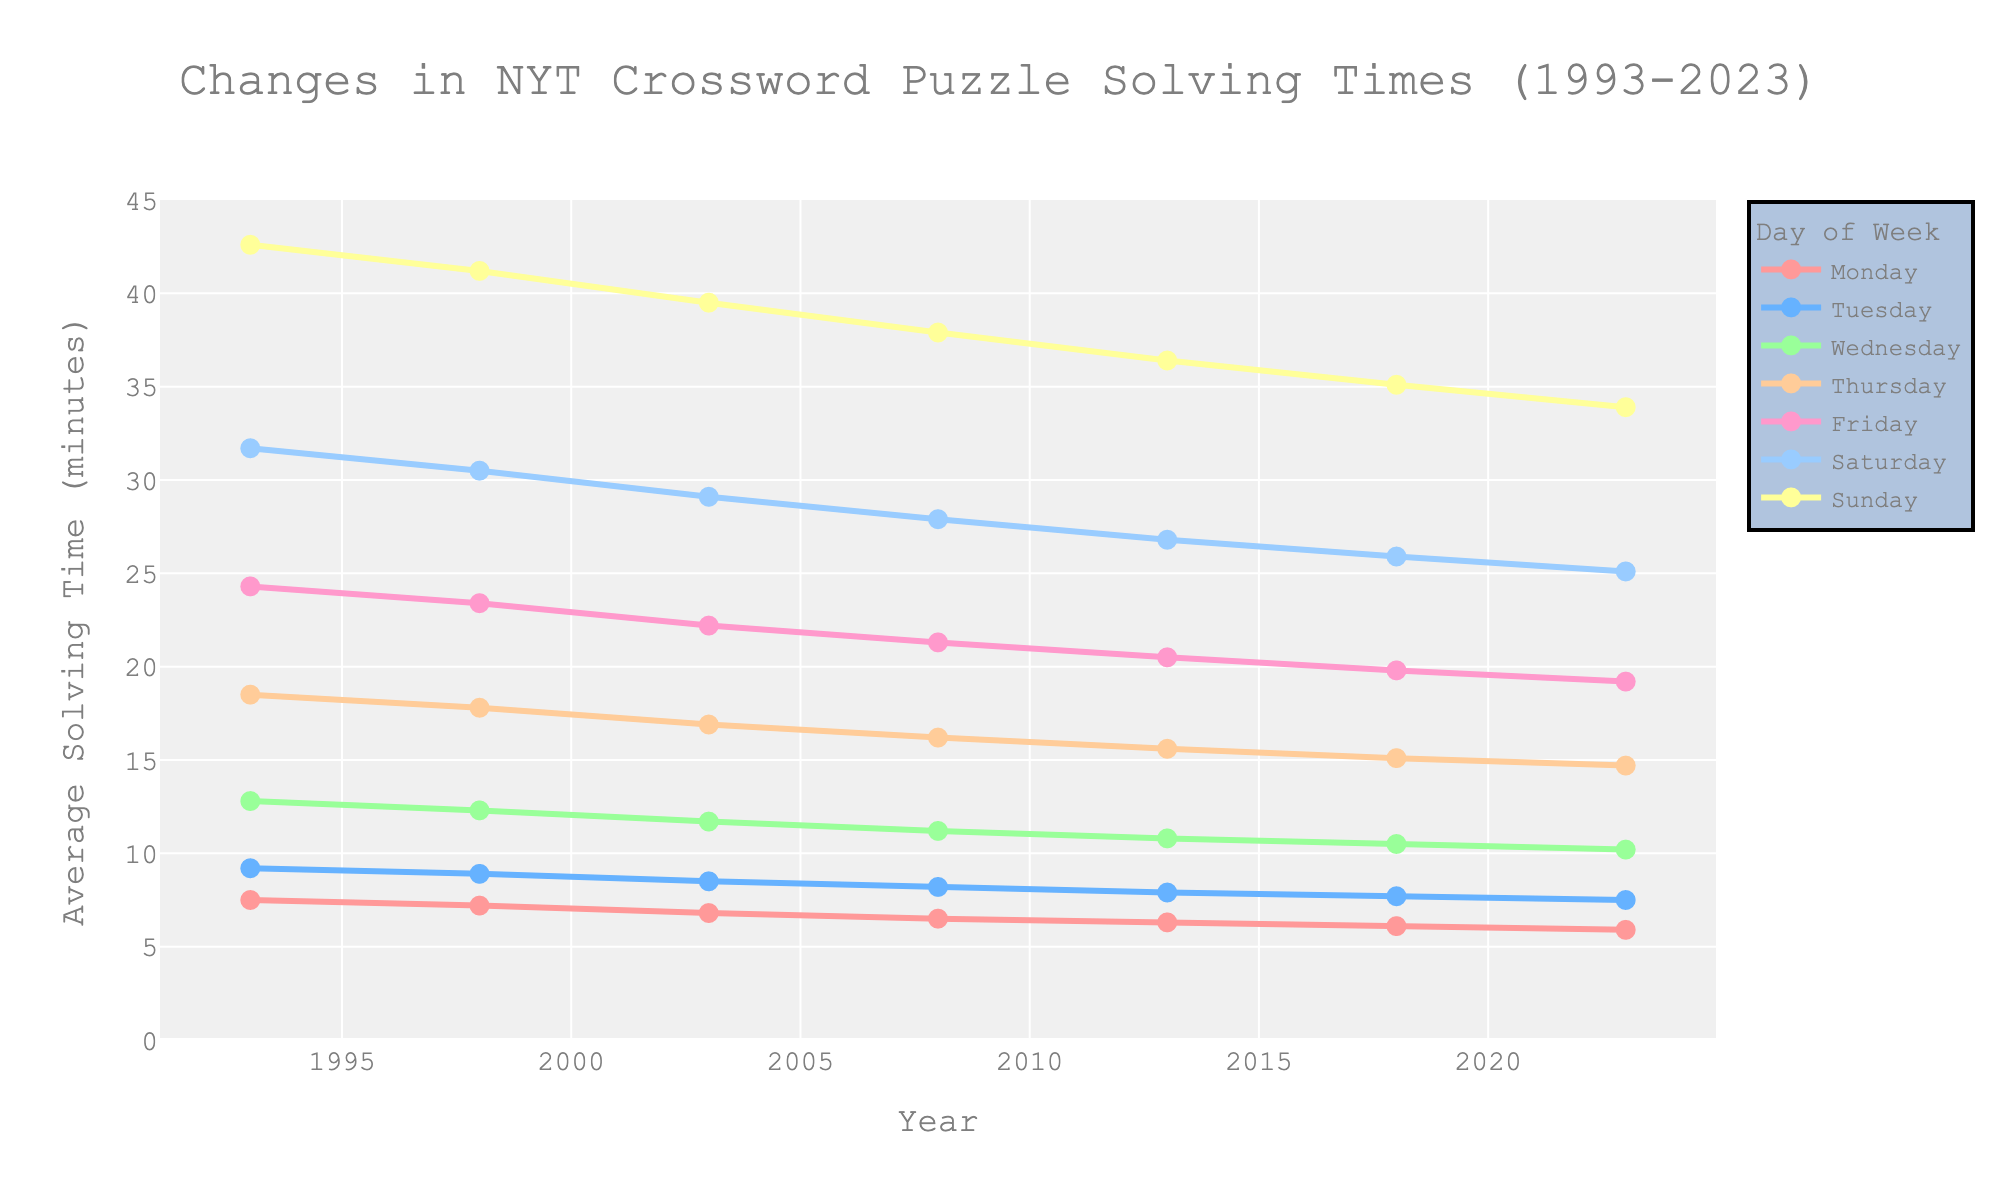What is the overall trend in solving times for Wednesday NYT crossword puzzles from 1993 to 2023? The solving times for Wednesday have a downward trend over the years from 1993 to 2023. In 1993, the average solving time was 12.8 minutes, and it gradually decreased to 10.2 minutes by 2023.
Answer: Downward Which day had the highest average solving time in 2023, and what was the time? In 2023, Sunday had the highest average solving time, which was 33.9 minutes.
Answer: Sunday, 33.9 minutes Compare the average solving times for Friday and Saturday in 2003. Which day had a higher solving time, and by how much? For 2003, Friday had an average solving time of 22.2 minutes, and Saturday had 29.1 minutes. Saturday's time was higher by 6.9 minutes.
Answer: Saturday, 6.9 minutes What was the difference in average solving times for Thursday puzzles between 1993 and 2023? In 1993, the average solving time for Thursday was 18.5 minutes, and it dropped to 14.7 minutes in 2023. The difference is 18.5 - 14.7 = 3.8 minutes.
Answer: 3.8 minutes By how many minutes did the average solving times for Monday puzzles decrease from 1993 to 2023? The average solving time for Monday puzzles in 1993 was 7.5 minutes, and it decreased to 5.9 minutes by 2023. The decrease is 7.5 - 5.9 = 1.6 minutes.
Answer: 1.6 minutes Observe the color indicating Saturday in the figure. Describe its trend from 1993 to 2023. The color indicating Saturday puzzles shows a consistent decrease in solving times from 31.7 minutes in 1993 to 25.1 minutes in 2023, indicating a downward trend.
Answer: Downward trend Which day of the week shows the smallest difference in average solving times between 1993 and 2023? For Monday, the solving time difference is 7.5 - 5.9 = 1.6 minutes. This is the smallest difference compared to other days of the week.
Answer: Monday Which year saw the largest decrease for the Tuesday puzzles compared to the previous year in the dataset? To determine this, compare the solving times between each pair of consecutive years. The largest decrease is between 1998 (8.9 minutes) and 2003 (8.5 minutes), which is 0.4 minutes.
Answer: 1998 to 2003 Identify two years where Sunday solving times decreased but Friday solving times remained the same or decreased less. The notable intervals where these conditions hold are 1998 to 2003 (Sunday: 41.2 to 39.5, decrease by 1.7; Friday: 23.4 to 22.2, decrease by 1.2) and 2018 to 2023 (Sunday: 35.1 to 33.9, decrease by 1.2; Friday: 19.8 to 19.2, decrease by 0.6).
Answer: 1998 to 2003, 2018 to 2023 